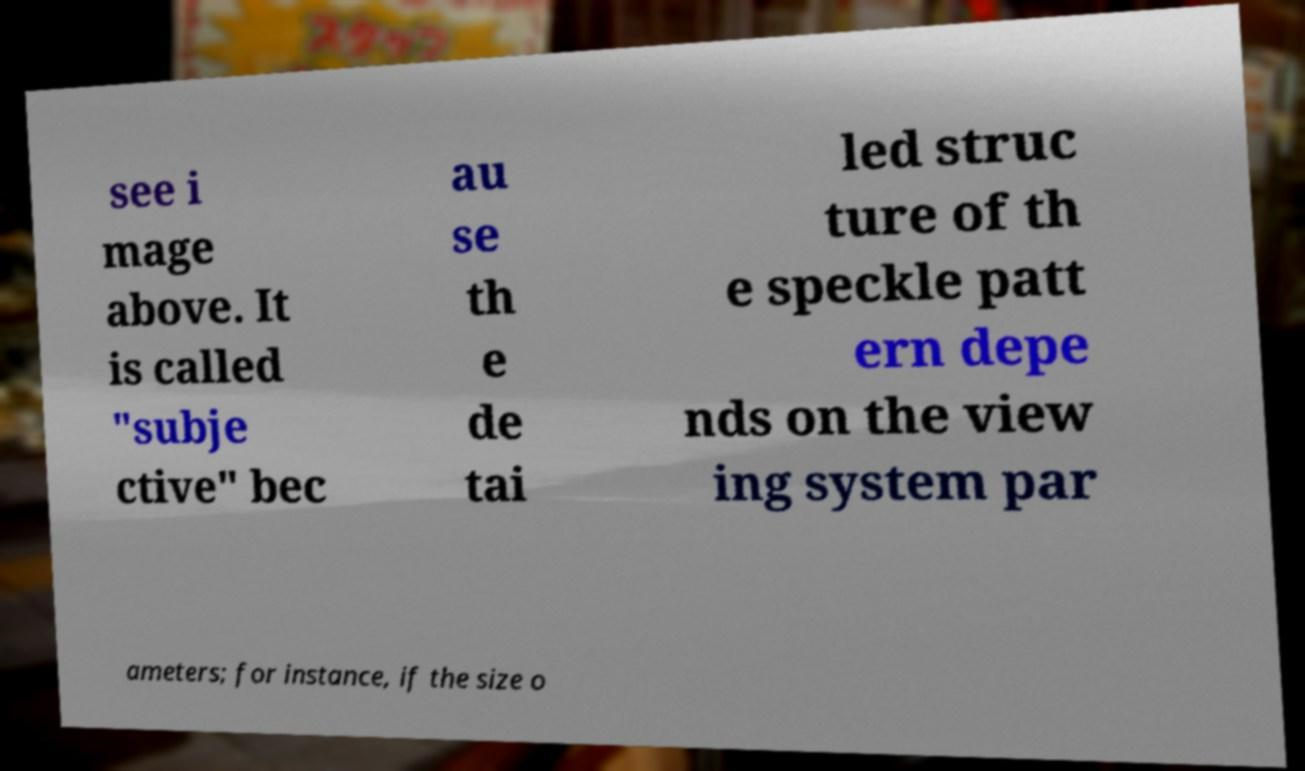Please read and relay the text visible in this image. What does it say? see i mage above. It is called "subje ctive" bec au se th e de tai led struc ture of th e speckle patt ern depe nds on the view ing system par ameters; for instance, if the size o 